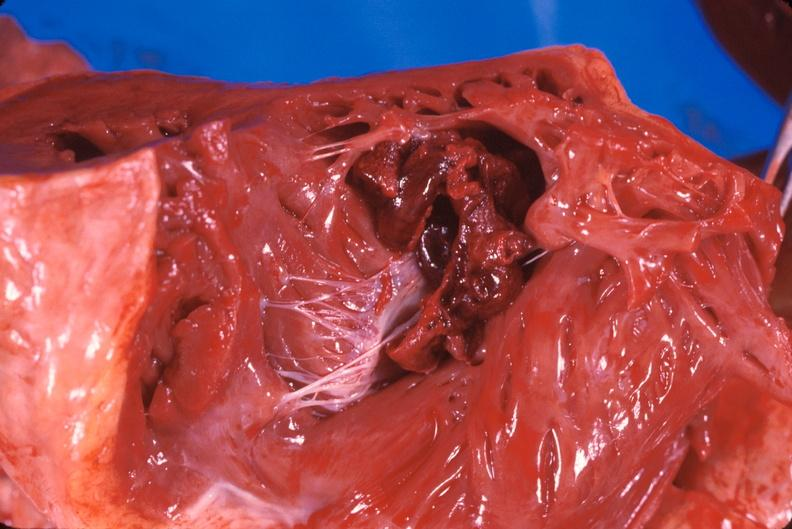s cardiovascular present?
Answer the question using a single word or phrase. Yes 